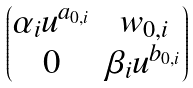<formula> <loc_0><loc_0><loc_500><loc_500>\begin{pmatrix} \alpha _ { i } u ^ { a _ { 0 , i } } & w _ { 0 , i } \\ 0 & \beta _ { i } u ^ { b _ { 0 , i } } \end{pmatrix}</formula> 